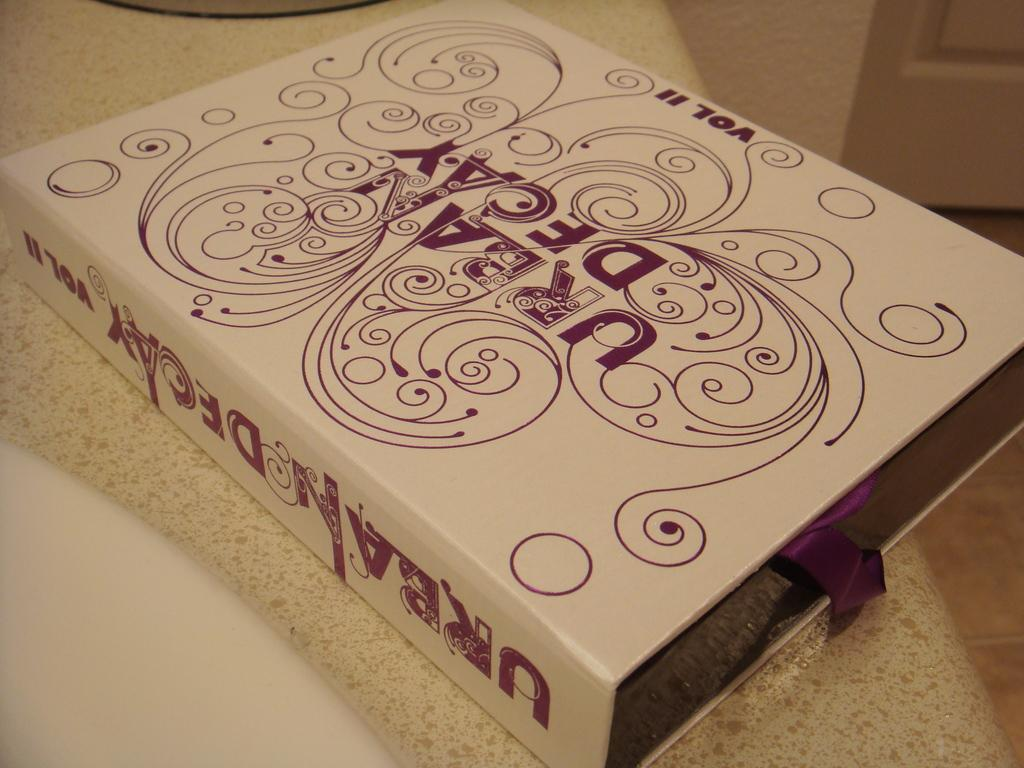<image>
Relay a brief, clear account of the picture shown. A book titled Urban Decay Vol II sits on a counter next to a sink. 